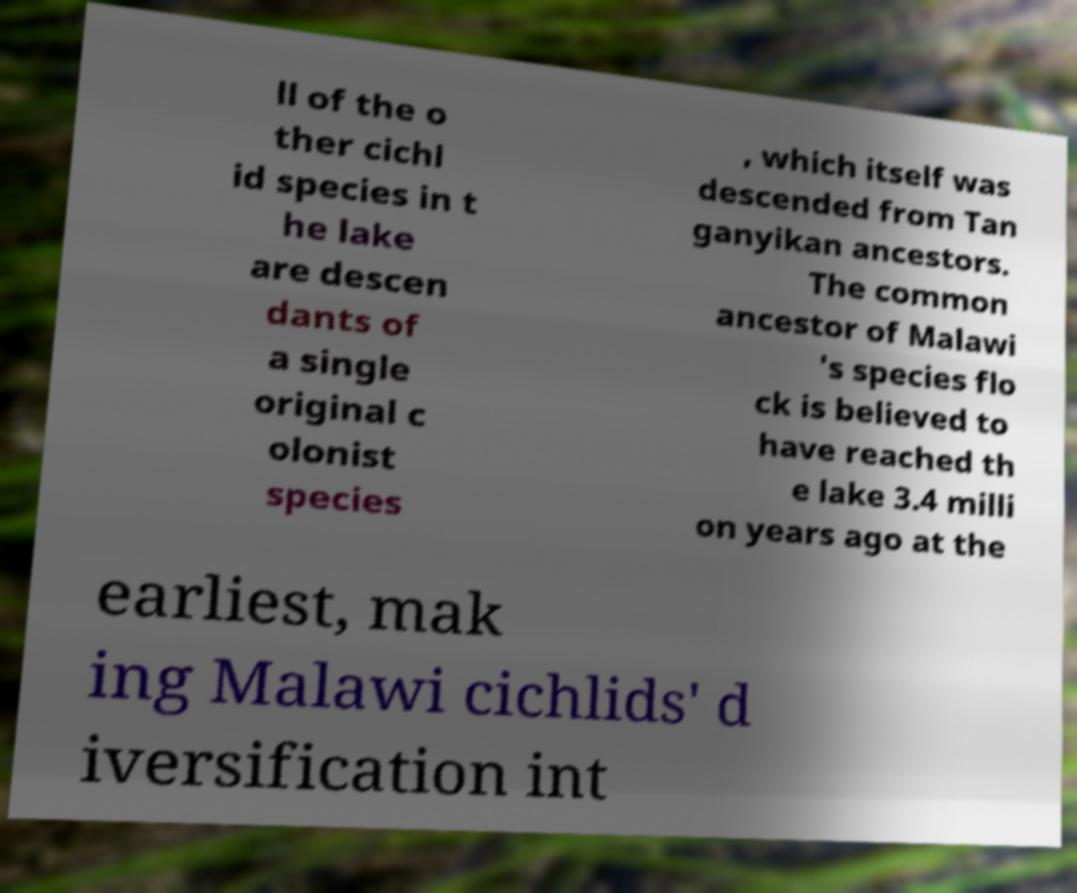Could you assist in decoding the text presented in this image and type it out clearly? ll of the o ther cichl id species in t he lake are descen dants of a single original c olonist species , which itself was descended from Tan ganyikan ancestors. The common ancestor of Malawi 's species flo ck is believed to have reached th e lake 3.4 milli on years ago at the earliest, mak ing Malawi cichlids' d iversification int 